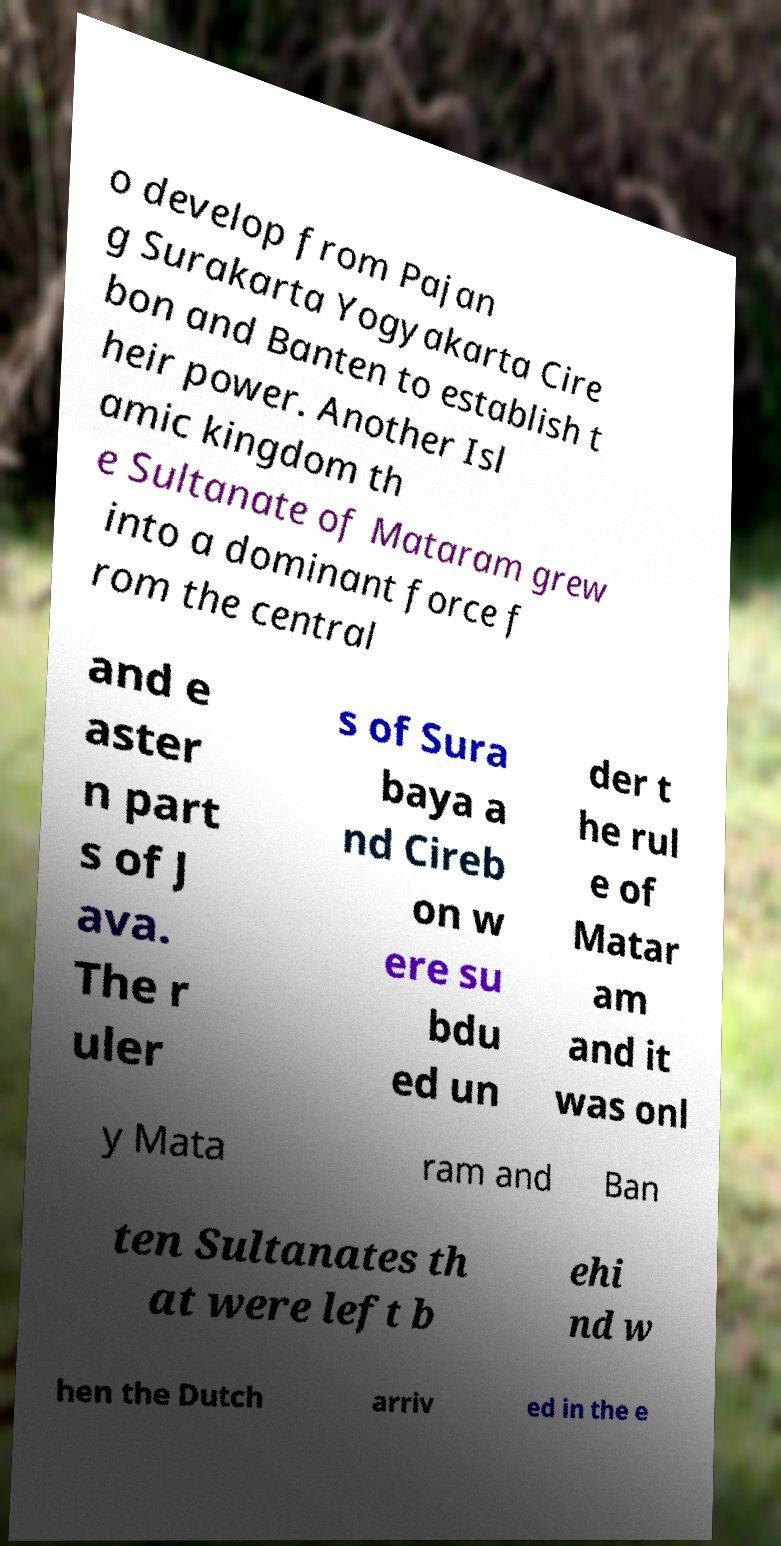For documentation purposes, I need the text within this image transcribed. Could you provide that? o develop from Pajan g Surakarta Yogyakarta Cire bon and Banten to establish t heir power. Another Isl amic kingdom th e Sultanate of Mataram grew into a dominant force f rom the central and e aster n part s of J ava. The r uler s of Sura baya a nd Cireb on w ere su bdu ed un der t he rul e of Matar am and it was onl y Mata ram and Ban ten Sultanates th at were left b ehi nd w hen the Dutch arriv ed in the e 